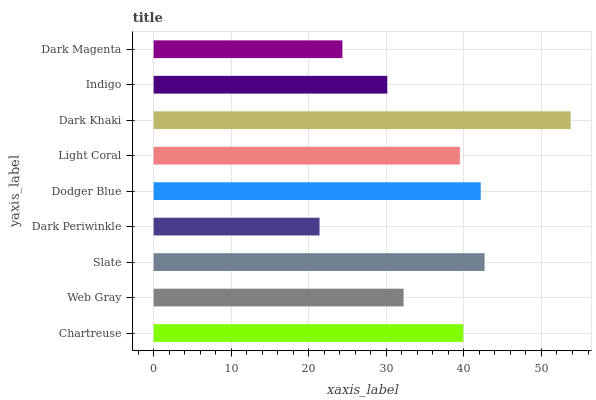Is Dark Periwinkle the minimum?
Answer yes or no. Yes. Is Dark Khaki the maximum?
Answer yes or no. Yes. Is Web Gray the minimum?
Answer yes or no. No. Is Web Gray the maximum?
Answer yes or no. No. Is Chartreuse greater than Web Gray?
Answer yes or no. Yes. Is Web Gray less than Chartreuse?
Answer yes or no. Yes. Is Web Gray greater than Chartreuse?
Answer yes or no. No. Is Chartreuse less than Web Gray?
Answer yes or no. No. Is Light Coral the high median?
Answer yes or no. Yes. Is Light Coral the low median?
Answer yes or no. Yes. Is Indigo the high median?
Answer yes or no. No. Is Dark Khaki the low median?
Answer yes or no. No. 